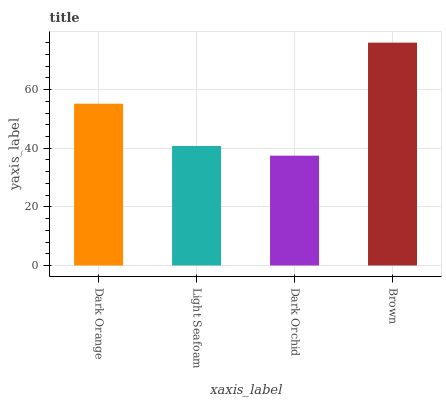Is Dark Orchid the minimum?
Answer yes or no. Yes. Is Brown the maximum?
Answer yes or no. Yes. Is Light Seafoam the minimum?
Answer yes or no. No. Is Light Seafoam the maximum?
Answer yes or no. No. Is Dark Orange greater than Light Seafoam?
Answer yes or no. Yes. Is Light Seafoam less than Dark Orange?
Answer yes or no. Yes. Is Light Seafoam greater than Dark Orange?
Answer yes or no. No. Is Dark Orange less than Light Seafoam?
Answer yes or no. No. Is Dark Orange the high median?
Answer yes or no. Yes. Is Light Seafoam the low median?
Answer yes or no. Yes. Is Light Seafoam the high median?
Answer yes or no. No. Is Dark Orange the low median?
Answer yes or no. No. 